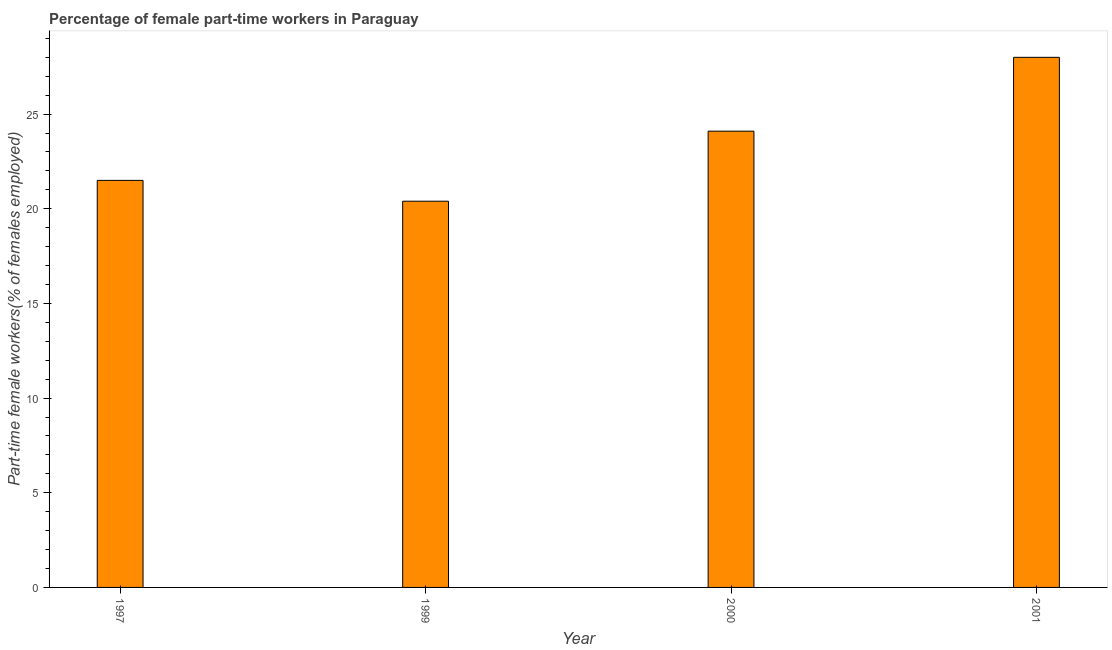Does the graph contain grids?
Ensure brevity in your answer.  No. What is the title of the graph?
Make the answer very short. Percentage of female part-time workers in Paraguay. What is the label or title of the X-axis?
Offer a terse response. Year. What is the label or title of the Y-axis?
Make the answer very short. Part-time female workers(% of females employed). Across all years, what is the maximum percentage of part-time female workers?
Offer a terse response. 28. Across all years, what is the minimum percentage of part-time female workers?
Make the answer very short. 20.4. In which year was the percentage of part-time female workers maximum?
Give a very brief answer. 2001. In which year was the percentage of part-time female workers minimum?
Keep it short and to the point. 1999. What is the sum of the percentage of part-time female workers?
Your answer should be very brief. 94. What is the average percentage of part-time female workers per year?
Keep it short and to the point. 23.5. What is the median percentage of part-time female workers?
Offer a very short reply. 22.8. In how many years, is the percentage of part-time female workers greater than 25 %?
Keep it short and to the point. 1. What is the ratio of the percentage of part-time female workers in 1997 to that in 2001?
Make the answer very short. 0.77. In how many years, is the percentage of part-time female workers greater than the average percentage of part-time female workers taken over all years?
Give a very brief answer. 2. Are all the bars in the graph horizontal?
Your response must be concise. No. What is the difference between two consecutive major ticks on the Y-axis?
Make the answer very short. 5. Are the values on the major ticks of Y-axis written in scientific E-notation?
Your response must be concise. No. What is the Part-time female workers(% of females employed) in 1997?
Provide a short and direct response. 21.5. What is the Part-time female workers(% of females employed) in 1999?
Offer a terse response. 20.4. What is the Part-time female workers(% of females employed) of 2000?
Keep it short and to the point. 24.1. What is the Part-time female workers(% of females employed) in 2001?
Offer a very short reply. 28. What is the difference between the Part-time female workers(% of females employed) in 1997 and 2000?
Keep it short and to the point. -2.6. What is the difference between the Part-time female workers(% of females employed) in 1999 and 2000?
Your answer should be very brief. -3.7. What is the difference between the Part-time female workers(% of females employed) in 1999 and 2001?
Your response must be concise. -7.6. What is the difference between the Part-time female workers(% of females employed) in 2000 and 2001?
Give a very brief answer. -3.9. What is the ratio of the Part-time female workers(% of females employed) in 1997 to that in 1999?
Make the answer very short. 1.05. What is the ratio of the Part-time female workers(% of females employed) in 1997 to that in 2000?
Give a very brief answer. 0.89. What is the ratio of the Part-time female workers(% of females employed) in 1997 to that in 2001?
Your answer should be compact. 0.77. What is the ratio of the Part-time female workers(% of females employed) in 1999 to that in 2000?
Provide a short and direct response. 0.85. What is the ratio of the Part-time female workers(% of females employed) in 1999 to that in 2001?
Provide a short and direct response. 0.73. What is the ratio of the Part-time female workers(% of females employed) in 2000 to that in 2001?
Offer a terse response. 0.86. 